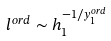<formula> <loc_0><loc_0><loc_500><loc_500>l ^ { o r d } \sim h _ { 1 } ^ { - 1 / y _ { 1 } ^ { o r d } }</formula> 